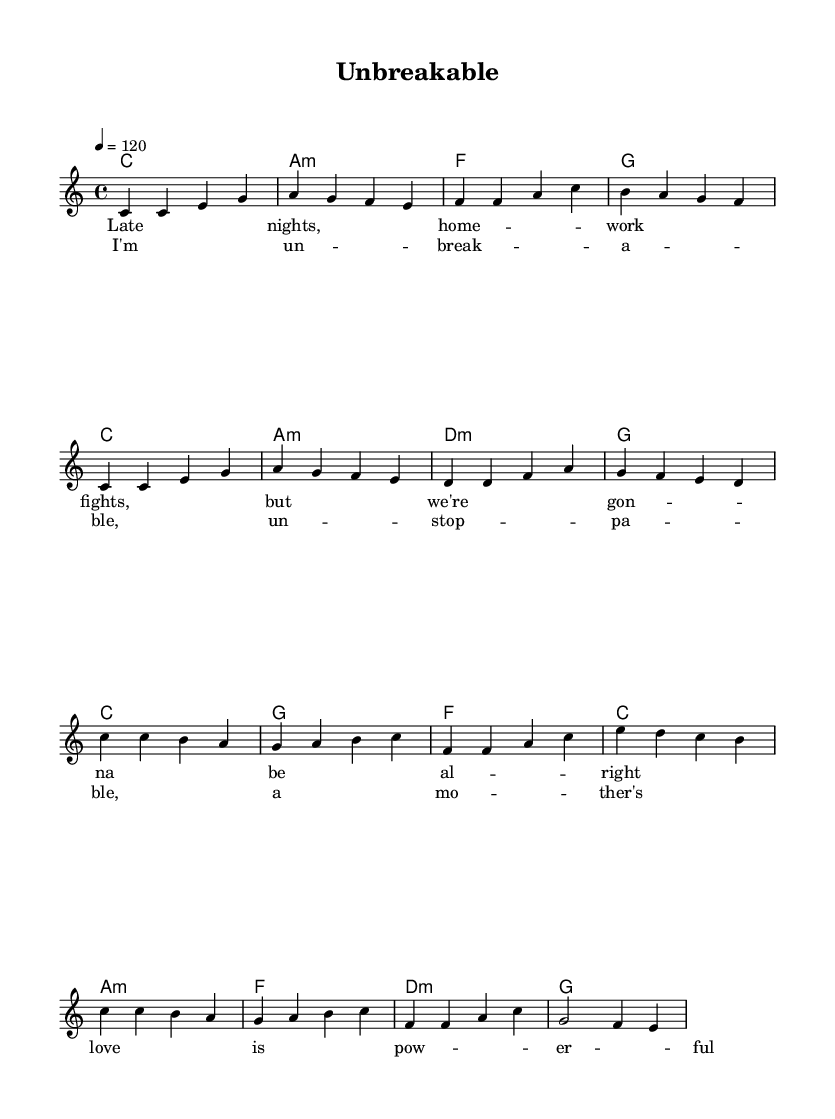What is the key signature of this music? The key signature is indicated in the global block and shows that there are no sharps or flats, which corresponds to C major.
Answer: C major What is the time signature of this piece? The time signature is found in the global section as well, where it clearly indicates a 4/4 time signature, meaning there are four beats in each measure.
Answer: 4/4 What is the tempo of the music? The tempo is indicated in the global section as "4 = 120", which means there are 120 beats per minute.
Answer: 120 How many measures are in the verse section? By counting each segment separated by the bar lines in the melody, we see there are eight measures in the verse section.
Answer: 8 How many lines of lyrics are provided for the chorus? The lyrics for the chorus can be counted, and there is a single continuous line of lyrics accompanied by the corresponding musical notes, indicating one line of text.
Answer: 1 What is the title of this song? The title is indicated at the top of the music sheet in the header section as "Unbreakable".
Answer: Unbreakable What type of chord is used as the first measure? The first measure of the harmonies section is labeled with a C major chord, which is identified by the root note C and the designation "1" following it.
Answer: C 